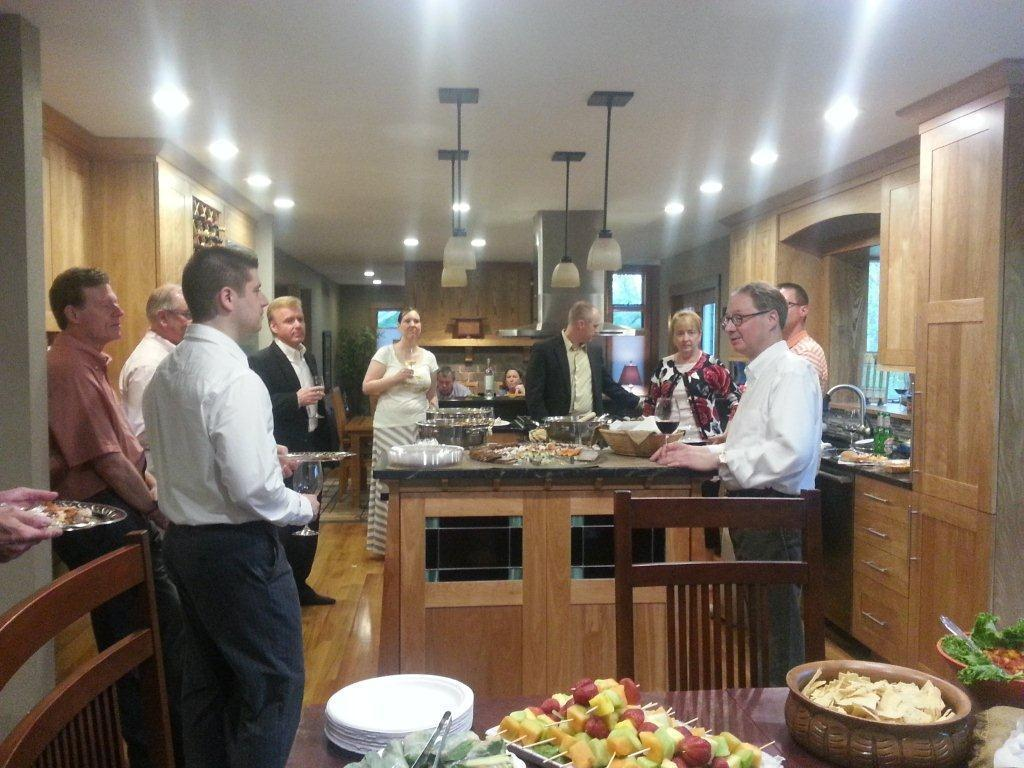What can be seen in the image? There are people, chairs, tables, bowls, plates, food items, cupboards, lights, a tap, a lamp, plants, and a ceiling in the image. What might the people be doing in the image? The people might be sitting, eating, or interacting with the objects in the image. What type of objects are present on the tables? The tables have bowls, plates, and food items on them. Can you describe the lighting in the image? There are lights and a lamp in the image, which provide illumination. What type of plants are in the image? The plants in the image are unspecified, but they are present. What type of hole can be seen in the image? There is no hole present in the image. What does the food taste like in the image? The taste of the food cannot be determined from the image alone, as taste is a sensory experience. 